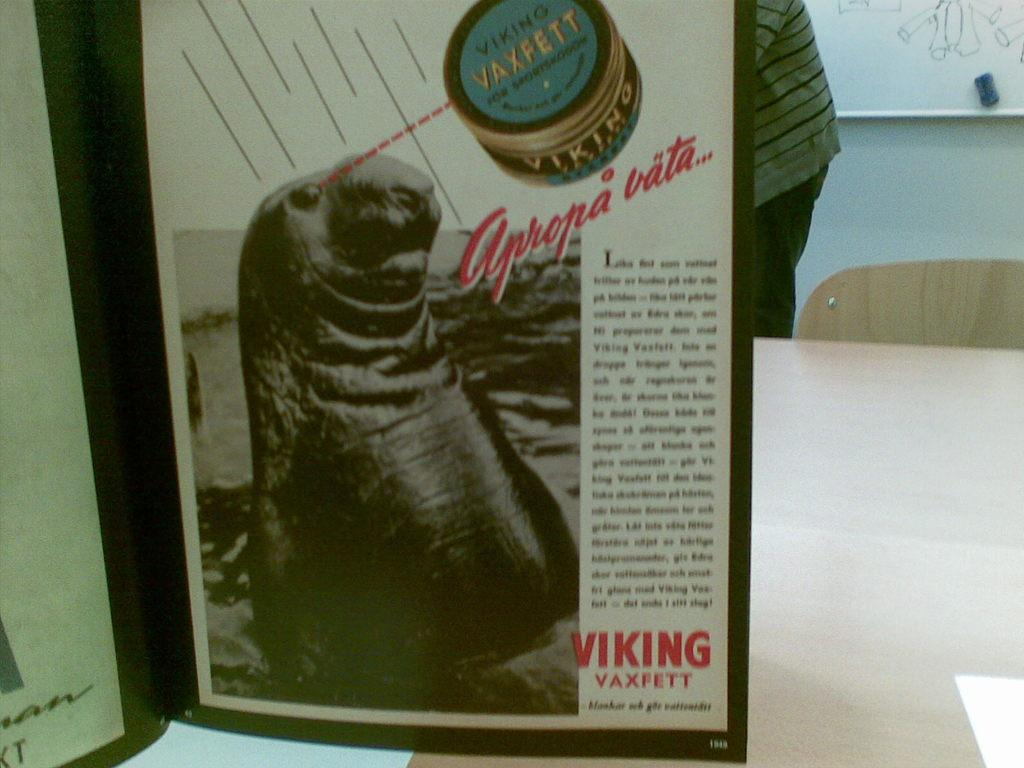<image>
Provide a brief description of the given image. A black and white advertisement for Viking Vaxfett. 